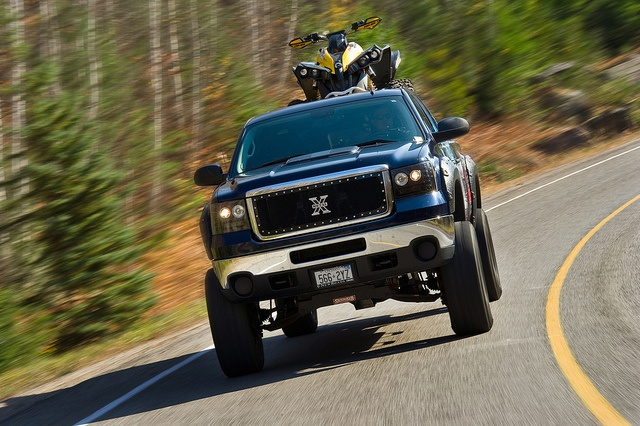Describe the objects in this image and their specific colors. I can see truck in olive, black, blue, darkblue, and gray tones, motorcycle in olive, black, gray, and darkgray tones, and people in olive, blue, and teal tones in this image. 